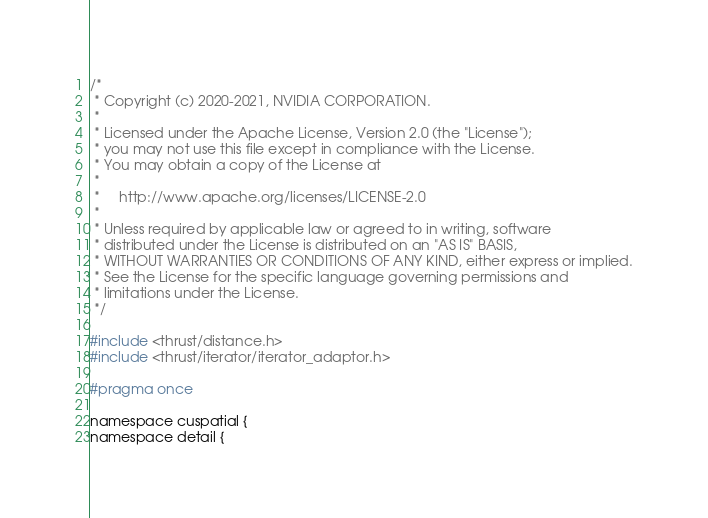<code> <loc_0><loc_0><loc_500><loc_500><_Cuda_>/*
 * Copyright (c) 2020-2021, NVIDIA CORPORATION.
 *
 * Licensed under the Apache License, Version 2.0 (the "License");
 * you may not use this file except in compliance with the License.
 * You may obtain a copy of the License at
 *
 *     http://www.apache.org/licenses/LICENSE-2.0
 *
 * Unless required by applicable law or agreed to in writing, software
 * distributed under the License is distributed on an "AS IS" BASIS,
 * WITHOUT WARRANTIES OR CONDITIONS OF ANY KIND, either express or implied.
 * See the License for the specific language governing permissions and
 * limitations under the License.
 */

#include <thrust/distance.h>
#include <thrust/iterator/iterator_adaptor.h>

#pragma once

namespace cuspatial {
namespace detail {
</code> 